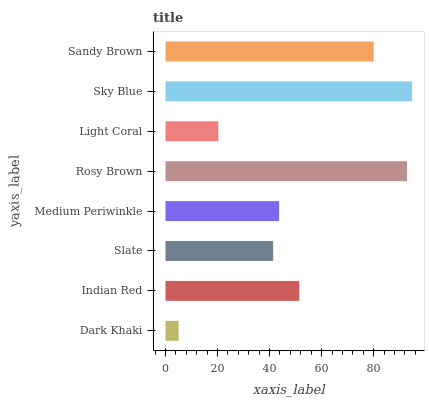Is Dark Khaki the minimum?
Answer yes or no. Yes. Is Sky Blue the maximum?
Answer yes or no. Yes. Is Indian Red the minimum?
Answer yes or no. No. Is Indian Red the maximum?
Answer yes or no. No. Is Indian Red greater than Dark Khaki?
Answer yes or no. Yes. Is Dark Khaki less than Indian Red?
Answer yes or no. Yes. Is Dark Khaki greater than Indian Red?
Answer yes or no. No. Is Indian Red less than Dark Khaki?
Answer yes or no. No. Is Indian Red the high median?
Answer yes or no. Yes. Is Medium Periwinkle the low median?
Answer yes or no. Yes. Is Sandy Brown the high median?
Answer yes or no. No. Is Slate the low median?
Answer yes or no. No. 